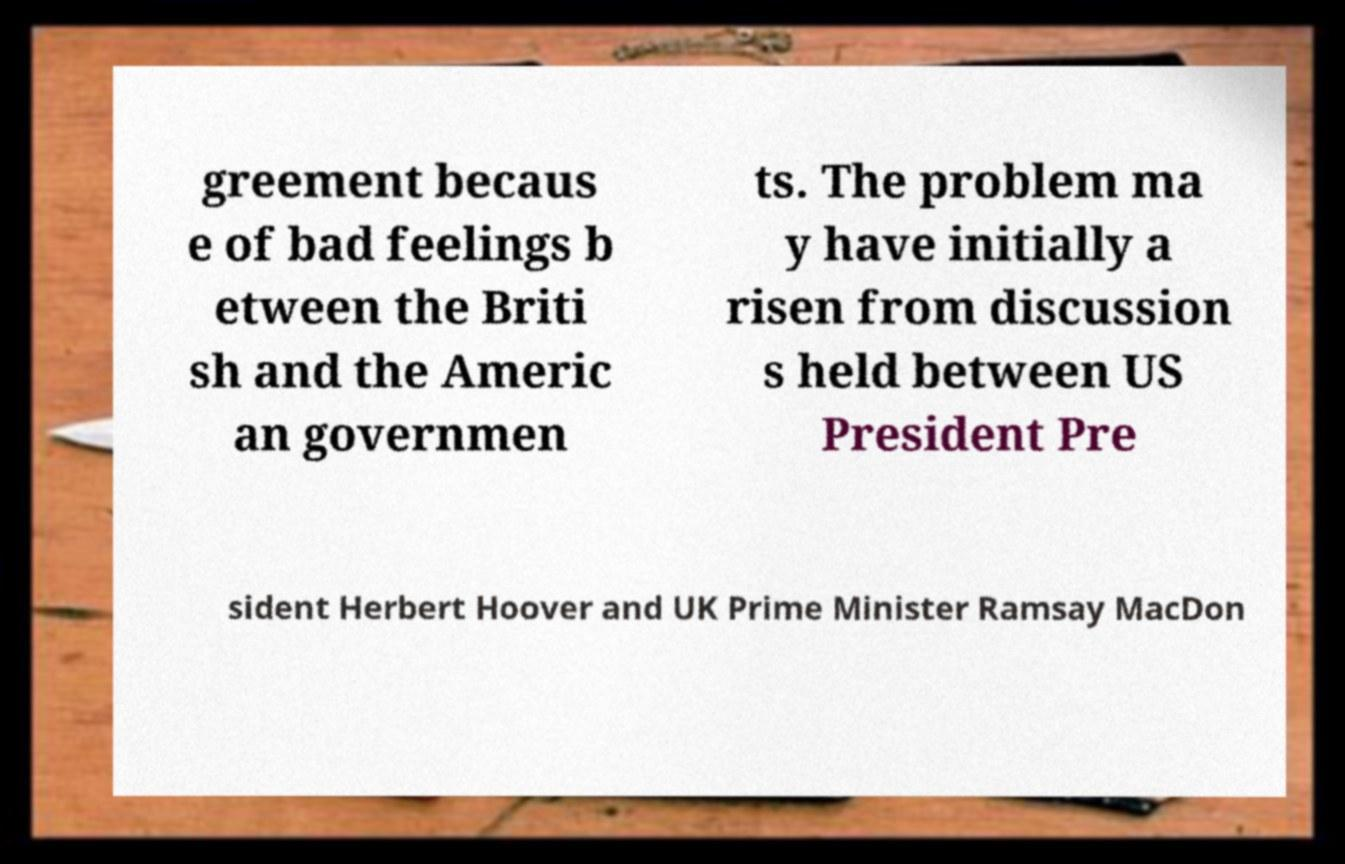There's text embedded in this image that I need extracted. Can you transcribe it verbatim? greement becaus e of bad feelings b etween the Briti sh and the Americ an governmen ts. The problem ma y have initially a risen from discussion s held between US President Pre sident Herbert Hoover and UK Prime Minister Ramsay MacDon 